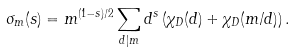Convert formula to latex. <formula><loc_0><loc_0><loc_500><loc_500>\sigma _ { m } ( s ) = m ^ { ( 1 - s ) / 2 } \sum _ { d | m } d ^ { s } \left ( \chi _ { D } ( d ) + \chi _ { D } ( m / d ) \right ) .</formula> 